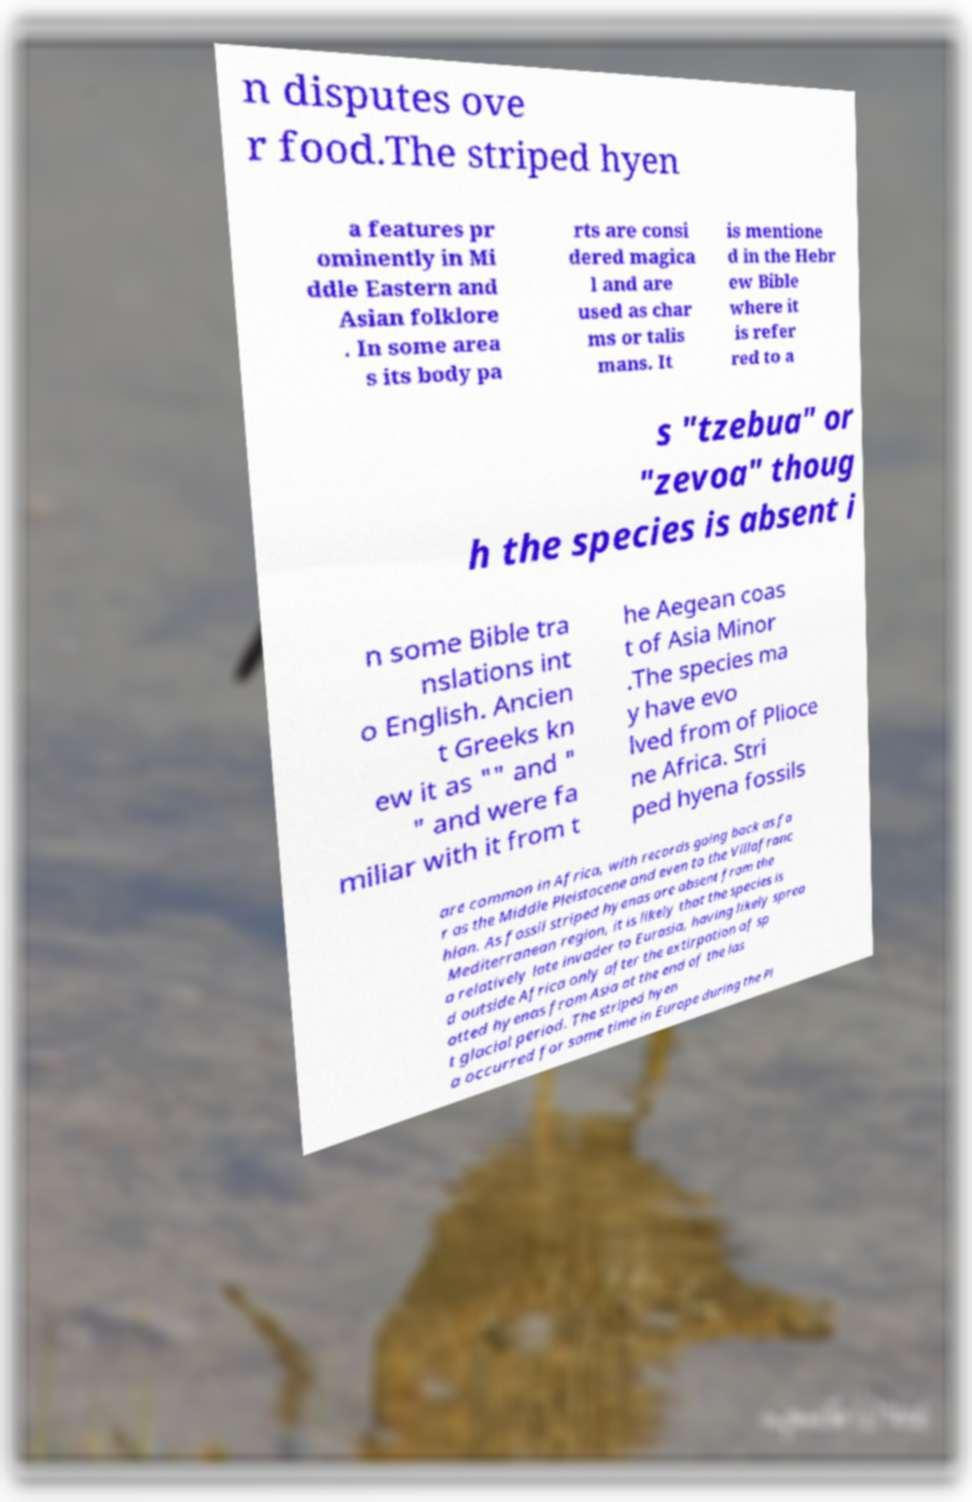Can you read and provide the text displayed in the image?This photo seems to have some interesting text. Can you extract and type it out for me? n disputes ove r food.The striped hyen a features pr ominently in Mi ddle Eastern and Asian folklore . In some area s its body pa rts are consi dered magica l and are used as char ms or talis mans. It is mentione d in the Hebr ew Bible where it is refer red to a s "tzebua" or "zevoa" thoug h the species is absent i n some Bible tra nslations int o English. Ancien t Greeks kn ew it as "" and " " and were fa miliar with it from t he Aegean coas t of Asia Minor .The species ma y have evo lved from of Plioce ne Africa. Stri ped hyena fossils are common in Africa, with records going back as fa r as the Middle Pleistocene and even to the Villafranc hian. As fossil striped hyenas are absent from the Mediterranean region, it is likely that the species is a relatively late invader to Eurasia, having likely sprea d outside Africa only after the extirpation of sp otted hyenas from Asia at the end of the las t glacial period. The striped hyen a occurred for some time in Europe during the Pl 